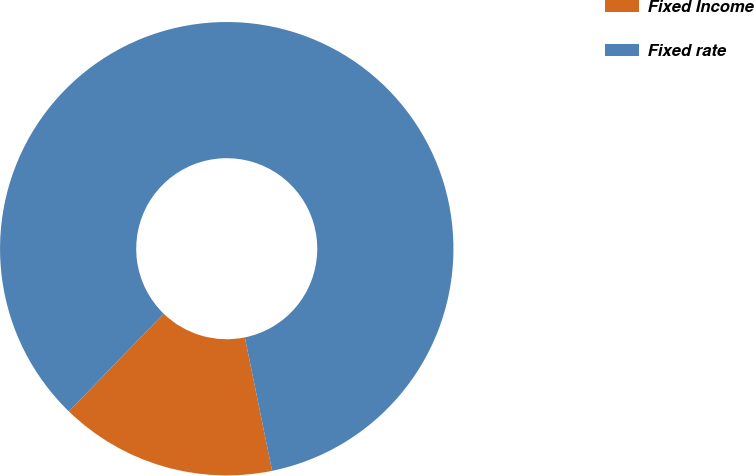Convert chart. <chart><loc_0><loc_0><loc_500><loc_500><pie_chart><fcel>Fixed Income<fcel>Fixed rate<nl><fcel>15.47%<fcel>84.53%<nl></chart> 